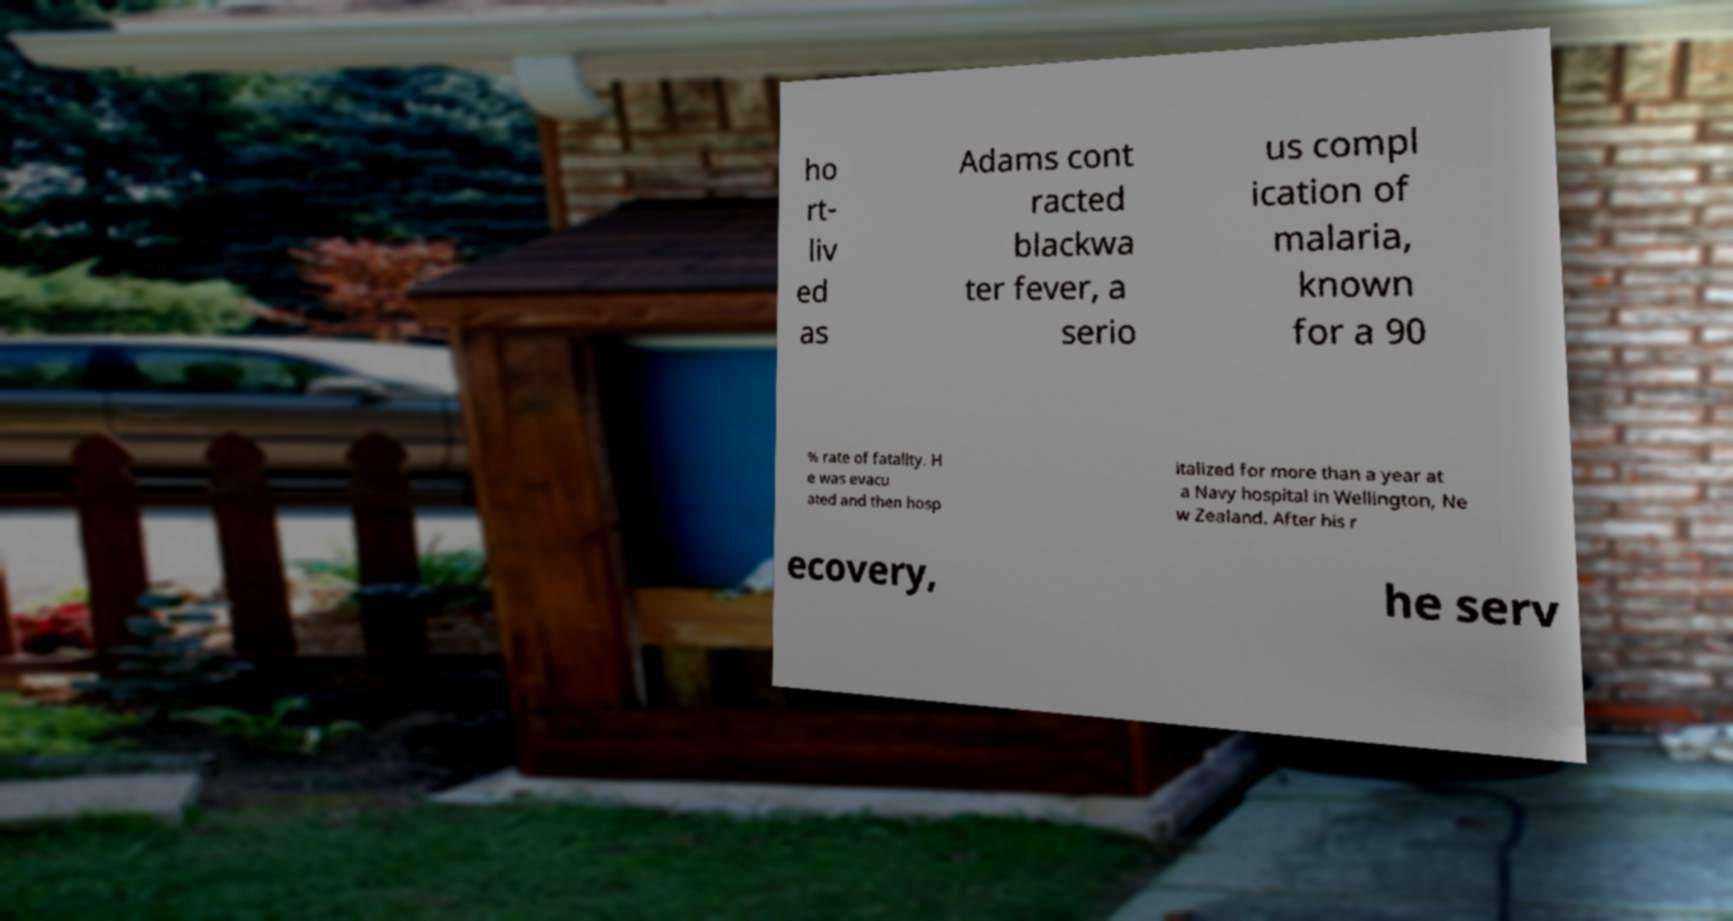What messages or text are displayed in this image? I need them in a readable, typed format. ho rt- liv ed as Adams cont racted blackwa ter fever, a serio us compl ication of malaria, known for a 90 % rate of fatality. H e was evacu ated and then hosp italized for more than a year at a Navy hospital in Wellington, Ne w Zealand. After his r ecovery, he serv 